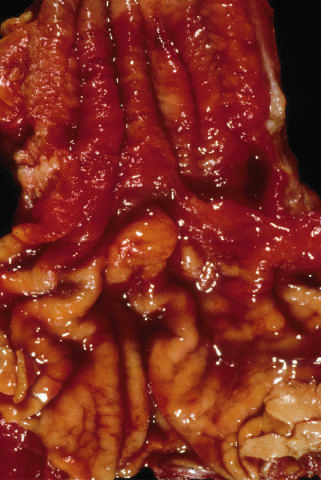do the areas of white chalky deposits remain within the predominantly metaplastic, reddish mucosa of the distal esophagus?
Answer the question using a single word or phrase. No 